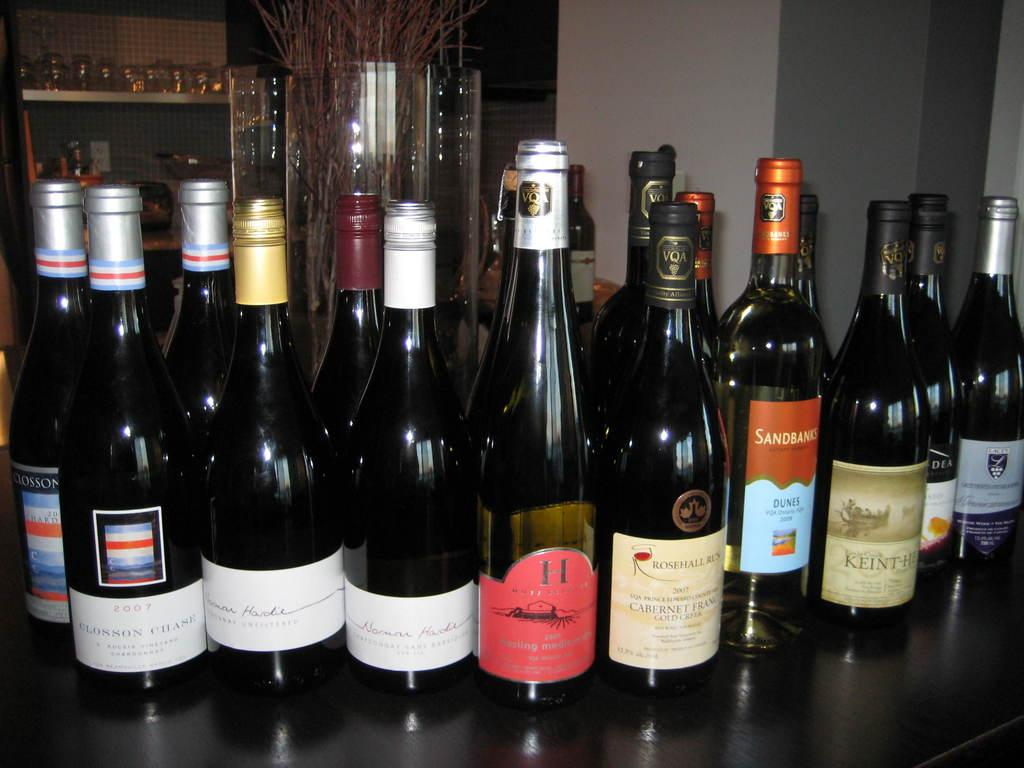<image>
Offer a succinct explanation of the picture presented. bottles of wined on a bar include Rose Hall and Dunes 